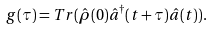<formula> <loc_0><loc_0><loc_500><loc_500>g ( \tau ) = T r ( \hat { \rho } ( 0 ) \hat { a } ^ { \dagger } ( t + \tau ) \hat { a } ( t ) ) .</formula> 